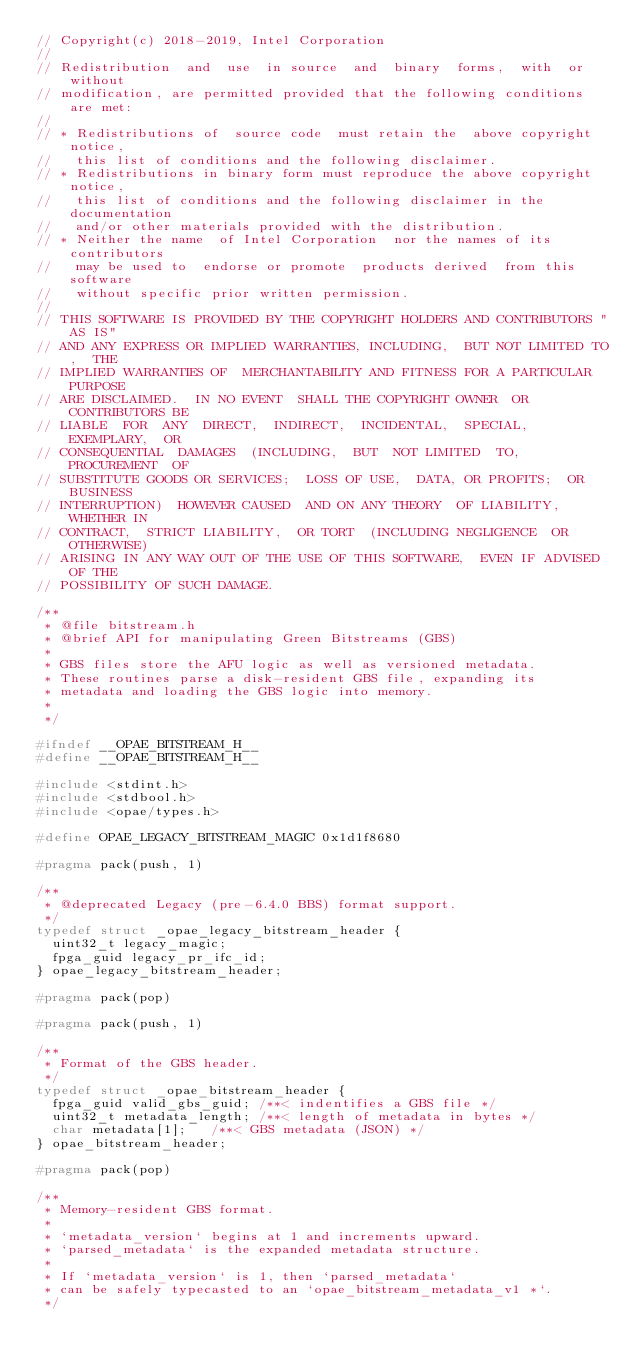Convert code to text. <code><loc_0><loc_0><loc_500><loc_500><_C_>// Copyright(c) 2018-2019, Intel Corporation
//
// Redistribution  and  use  in source  and  binary  forms,  with  or  without
// modification, are permitted provided that the following conditions are met:
//
// * Redistributions of  source code  must retain the  above copyright notice,
//   this list of conditions and the following disclaimer.
// * Redistributions in binary form must reproduce the above copyright notice,
//   this list of conditions and the following disclaimer in the documentation
//   and/or other materials provided with the distribution.
// * Neither the name  of Intel Corporation  nor the names of its contributors
//   may be used to  endorse or promote  products derived  from this  software
//   without specific prior written permission.
//
// THIS SOFTWARE IS PROVIDED BY THE COPYRIGHT HOLDERS AND CONTRIBUTORS "AS IS"
// AND ANY EXPRESS OR IMPLIED WARRANTIES, INCLUDING,  BUT NOT LIMITED TO,  THE
// IMPLIED WARRANTIES OF  MERCHANTABILITY AND FITNESS FOR A PARTICULAR PURPOSE
// ARE DISCLAIMED.  IN NO EVENT  SHALL THE COPYRIGHT OWNER  OR CONTRIBUTORS BE
// LIABLE  FOR  ANY  DIRECT,  INDIRECT,  INCIDENTAL,  SPECIAL,  EXEMPLARY,  OR
// CONSEQUENTIAL  DAMAGES  (INCLUDING,  BUT  NOT LIMITED  TO,  PROCUREMENT  OF
// SUBSTITUTE GOODS OR SERVICES;  LOSS OF USE,  DATA, OR PROFITS;  OR BUSINESS
// INTERRUPTION)  HOWEVER CAUSED  AND ON ANY THEORY  OF LIABILITY,  WHETHER IN
// CONTRACT,  STRICT LIABILITY,  OR TORT  (INCLUDING NEGLIGENCE  OR OTHERWISE)
// ARISING IN ANY WAY OUT OF THE USE OF THIS SOFTWARE,  EVEN IF ADVISED OF THE
// POSSIBILITY OF SUCH DAMAGE.

/**
 * @file bitstream.h
 * @brief API for manipulating Green Bitstreams (GBS)
 *
 * GBS files store the AFU logic as well as versioned metadata.
 * These routines parse a disk-resident GBS file, expanding its
 * metadata and loading the GBS logic into memory.
 *
 */

#ifndef __OPAE_BITSTREAM_H__
#define __OPAE_BITSTREAM_H__

#include <stdint.h>
#include <stdbool.h>
#include <opae/types.h>

#define OPAE_LEGACY_BITSTREAM_MAGIC 0x1d1f8680

#pragma pack(push, 1)

/**
 * @deprecated Legacy (pre-6.4.0 BBS) format support.
 */
typedef struct _opae_legacy_bitstream_header {
	uint32_t legacy_magic;
	fpga_guid legacy_pr_ifc_id;
} opae_legacy_bitstream_header;

#pragma pack(pop)

#pragma pack(push, 1)

/**
 * Format of the GBS header.
 */
typedef struct _opae_bitstream_header {
	fpga_guid valid_gbs_guid;	/**< indentifies a GBS file */
	uint32_t metadata_length;	/**< length of metadata in bytes */
	char metadata[1];		/**< GBS metadata (JSON) */
} opae_bitstream_header;

#pragma pack(pop)

/**
 * Memory-resident GBS format.
 *
 * `metadata_version` begins at 1 and increments upward.
 * `parsed_metadata` is the expanded metadata structure.
 *
 * If `metadata_version` is 1, then `parsed_metadata`
 * can be safely typecasted to an `opae_bitstream_metadata_v1 *`.
 */</code> 